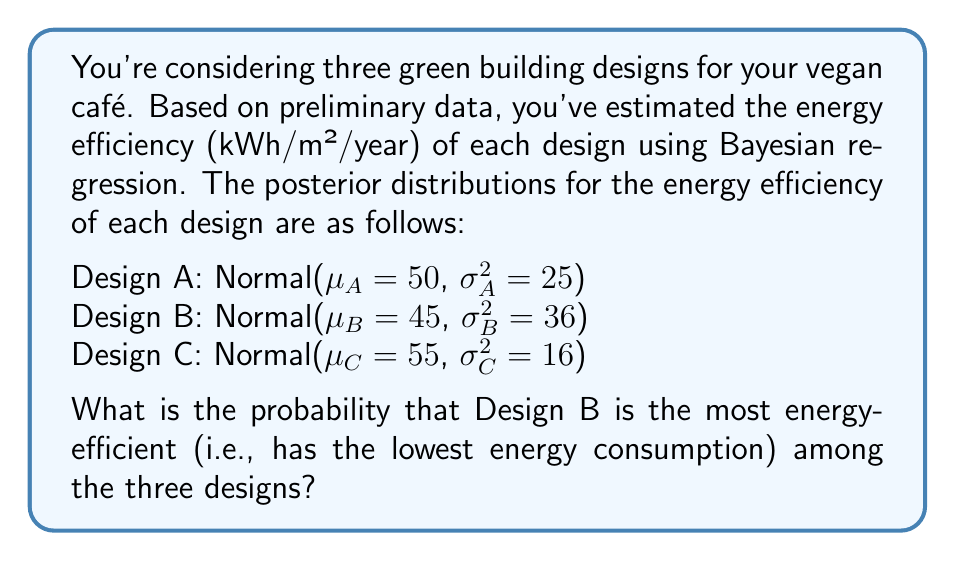Show me your answer to this math problem. To solve this problem, we need to calculate the probability that Design B's energy efficiency is lower than both Design A and Design C. We can approach this using the following steps:

1) First, let's define our random variables:
   $X_A \sim N(50, 25)$
   $X_B \sim N(45, 36)$
   $X_C \sim N(55, 16)$

2) We need to find $P(X_B < X_A \text{ and } X_B < X_C)$

3) Due to the independence of the designs, we can rewrite this as:
   $P(X_B < X_A) \times P(X_B < X_C)$

4) For $X_B < X_A$:
   $Z = X_A - X_B \sim N(\mu_A - \mu_B, \sigma_A^2 + \sigma_B^2)$
   $Z \sim N(50 - 45, 25 + 36) = N(5, 61)$

   $P(X_B < X_A) = P(Z > 0) = 1 - \Phi(\frac{0-5}{\sqrt{61}}) = 1 - \Phi(-0.64) = \Phi(0.64) \approx 0.7389$

5) For $X_B < X_C$:
   $W = X_C - X_B \sim N(\mu_C - \mu_B, \sigma_C^2 + \sigma_B^2)$
   $W \sim N(55 - 45, 16 + 36) = N(10, 52)$

   $P(X_B < X_C) = P(W > 0) = 1 - \Phi(\frac{0-10}{\sqrt{52}}) = 1 - \Phi(-1.39) = \Phi(1.39) \approx 0.9177$

6) Therefore, the probability that Design B is the most energy-efficient is:
   $P(X_B < X_A \text{ and } X_B < X_C) = 0.7389 \times 0.9177 \approx 0.6781$
Answer: The probability that Design B is the most energy-efficient among the three designs is approximately 0.6781 or 67.81%. 